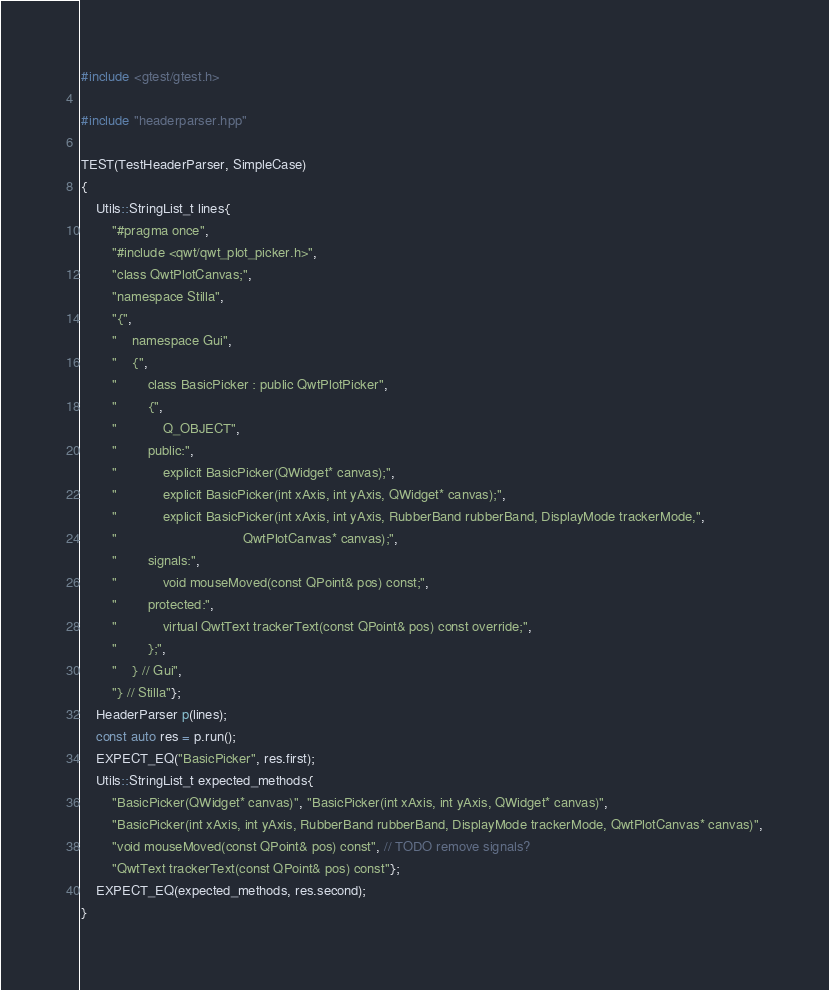<code> <loc_0><loc_0><loc_500><loc_500><_C++_>#include <gtest/gtest.h>

#include "headerparser.hpp"

TEST(TestHeaderParser, SimpleCase)
{
    Utils::StringList_t lines{
        "#pragma once",
        "#include <qwt/qwt_plot_picker.h>",
        "class QwtPlotCanvas;",
        "namespace Stilla",
        "{",
        "    namespace Gui",
        "    {",
        "        class BasicPicker : public QwtPlotPicker",
        "        {",
        "            Q_OBJECT",
        "        public:",
        "            explicit BasicPicker(QWidget* canvas);",
        "            explicit BasicPicker(int xAxis, int yAxis, QWidget* canvas);",
        "            explicit BasicPicker(int xAxis, int yAxis, RubberBand rubberBand, DisplayMode trackerMode,",
        "                                 QwtPlotCanvas* canvas);",
        "        signals:",
        "            void mouseMoved(const QPoint& pos) const;",
        "        protected:",
        "            virtual QwtText trackerText(const QPoint& pos) const override;",
        "        };",
        "    } // Gui",
        "} // Stilla"};
    HeaderParser p(lines);
    const auto res = p.run();
    EXPECT_EQ("BasicPicker", res.first);
    Utils::StringList_t expected_methods{
        "BasicPicker(QWidget* canvas)", "BasicPicker(int xAxis, int yAxis, QWidget* canvas)",
        "BasicPicker(int xAxis, int yAxis, RubberBand rubberBand, DisplayMode trackerMode, QwtPlotCanvas* canvas)",
        "void mouseMoved(const QPoint& pos) const", // TODO remove signals?
        "QwtText trackerText(const QPoint& pos) const"};
    EXPECT_EQ(expected_methods, res.second);
}</code> 